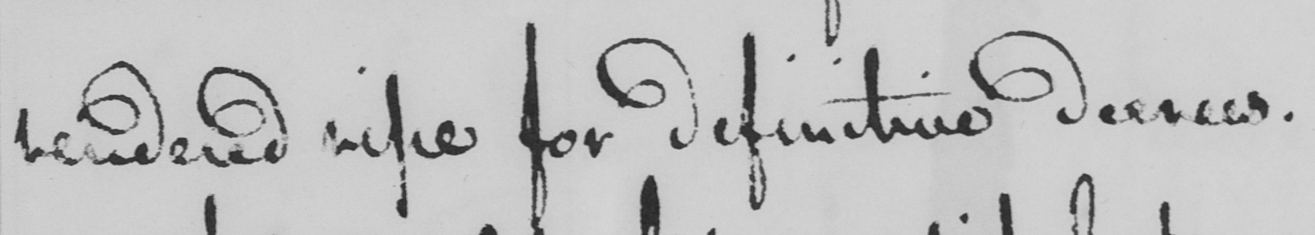What does this handwritten line say? rendered ripe for definitive decrees. 